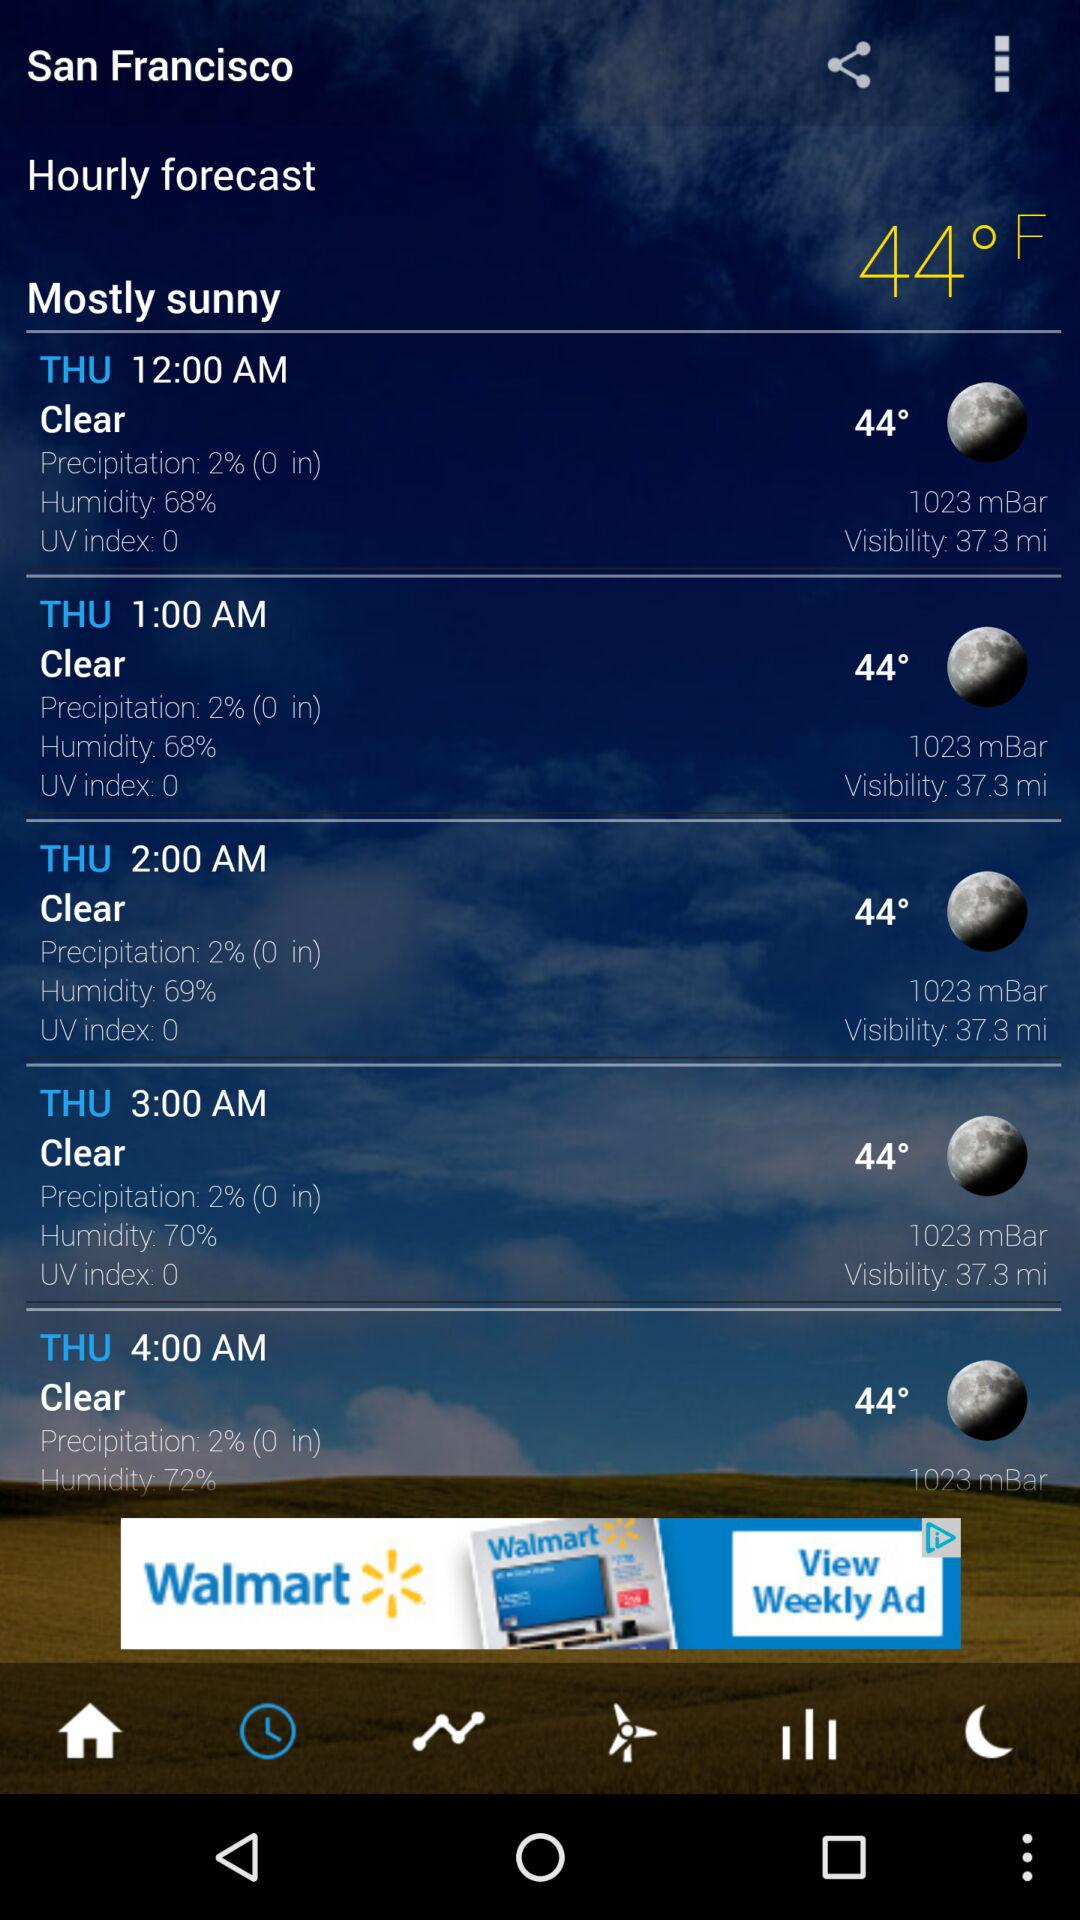What is the location? The location is San Francisco. 